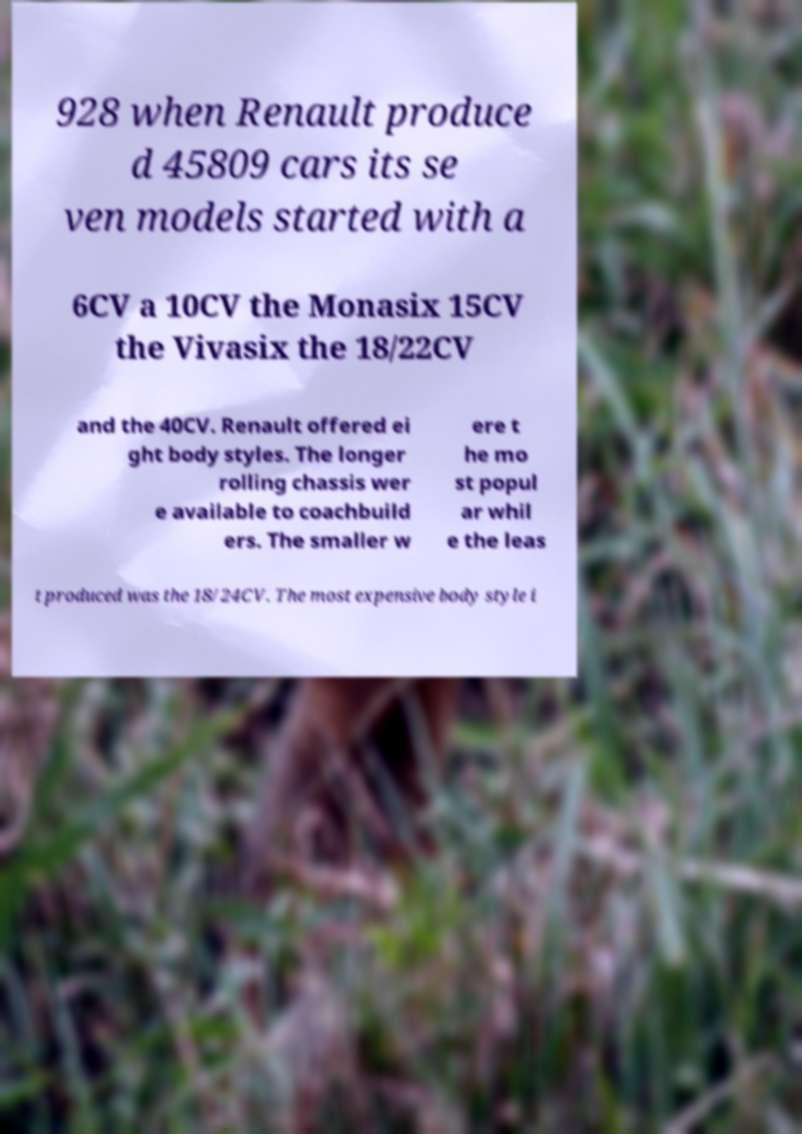Could you extract and type out the text from this image? 928 when Renault produce d 45809 cars its se ven models started with a 6CV a 10CV the Monasix 15CV the Vivasix the 18/22CV and the 40CV. Renault offered ei ght body styles. The longer rolling chassis wer e available to coachbuild ers. The smaller w ere t he mo st popul ar whil e the leas t produced was the 18/24CV. The most expensive body style i 